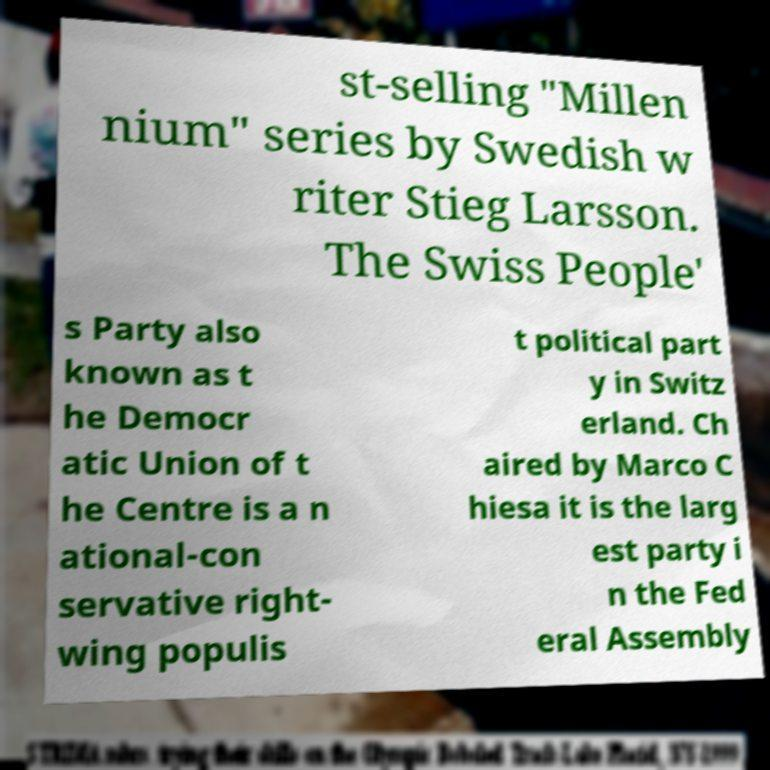Can you accurately transcribe the text from the provided image for me? st-selling "Millen nium" series by Swedish w riter Stieg Larsson. The Swiss People' s Party also known as t he Democr atic Union of t he Centre is a n ational-con servative right- wing populis t political part y in Switz erland. Ch aired by Marco C hiesa it is the larg est party i n the Fed eral Assembly 